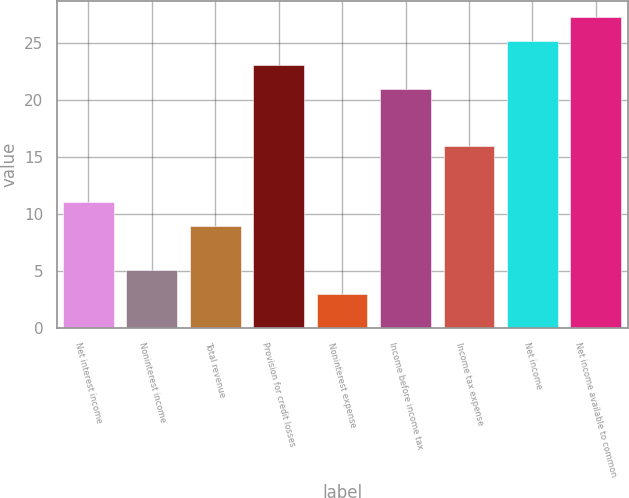Convert chart to OTSL. <chart><loc_0><loc_0><loc_500><loc_500><bar_chart><fcel>Net interest income<fcel>Noninterest income<fcel>Total revenue<fcel>Provision for credit losses<fcel>Noninterest expense<fcel>Income before income tax<fcel>Income tax expense<fcel>Net income<fcel>Net income available to common<nl><fcel>11.1<fcel>5.1<fcel>9<fcel>23.1<fcel>3<fcel>21<fcel>16<fcel>25.2<fcel>27.3<nl></chart> 